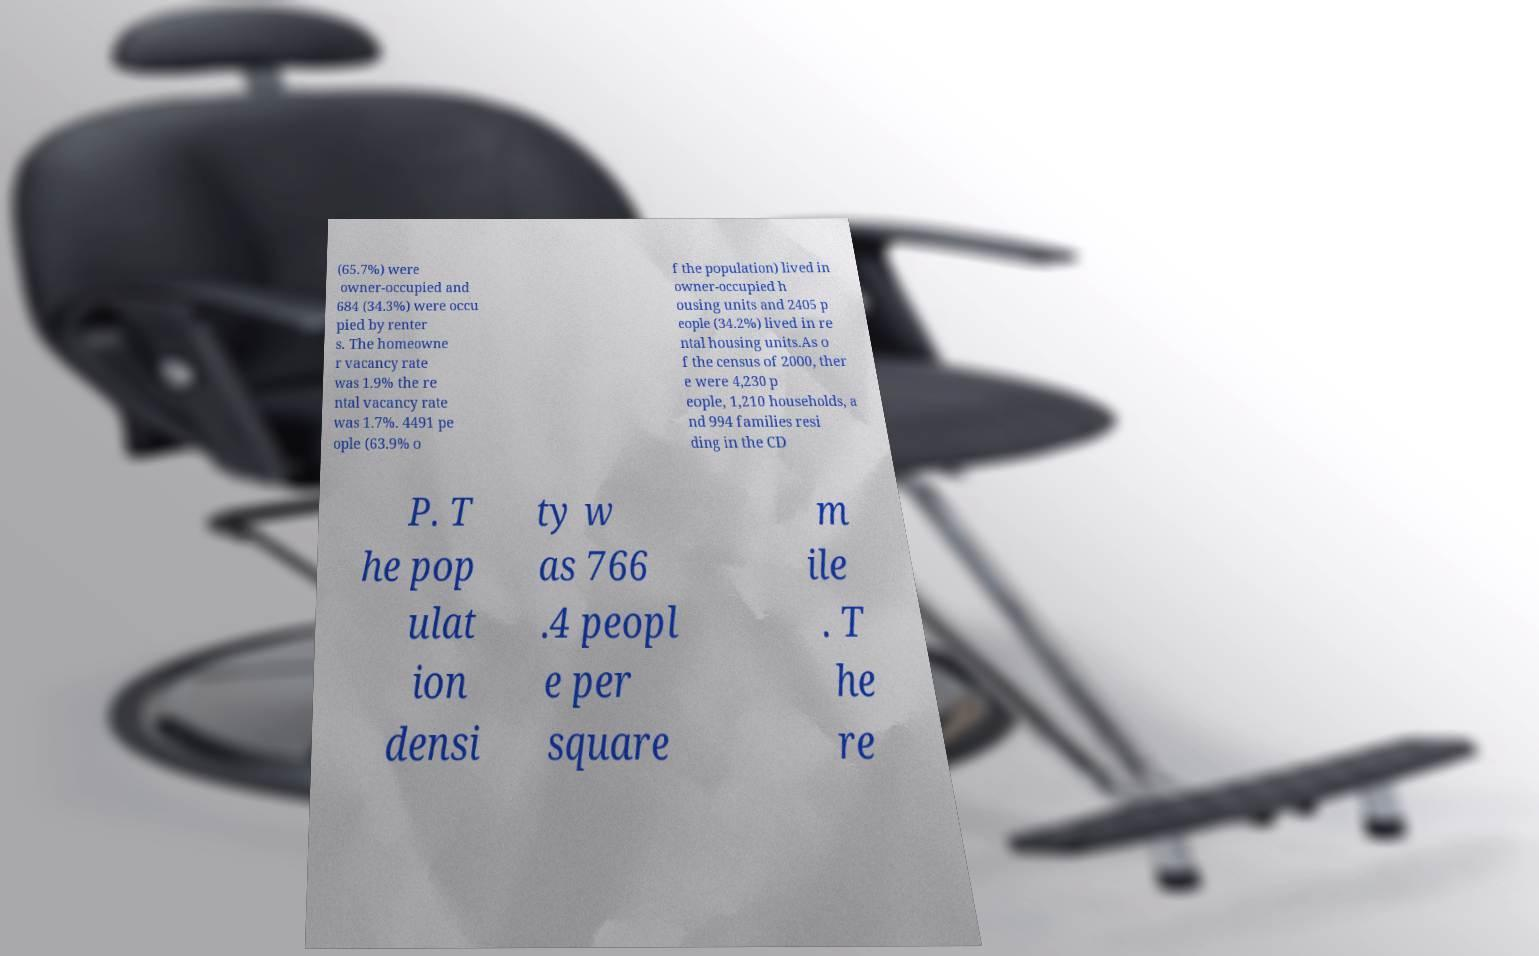For documentation purposes, I need the text within this image transcribed. Could you provide that? (65.7%) were owner-occupied and 684 (34.3%) were occu pied by renter s. The homeowne r vacancy rate was 1.9% the re ntal vacancy rate was 1.7%. 4491 pe ople (63.9% o f the population) lived in owner-occupied h ousing units and 2405 p eople (34.2%) lived in re ntal housing units.As o f the census of 2000, ther e were 4,230 p eople, 1,210 households, a nd 994 families resi ding in the CD P. T he pop ulat ion densi ty w as 766 .4 peopl e per square m ile . T he re 